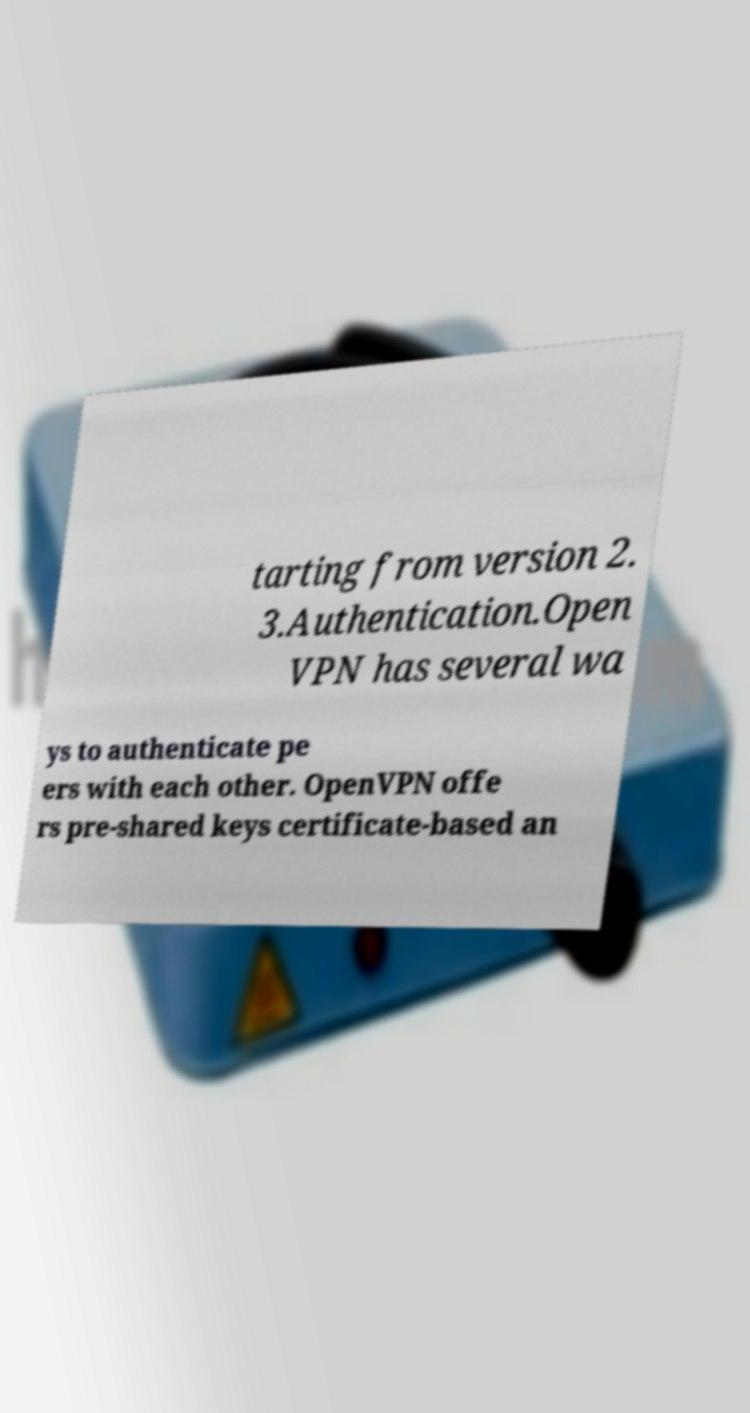There's text embedded in this image that I need extracted. Can you transcribe it verbatim? tarting from version 2. 3.Authentication.Open VPN has several wa ys to authenticate pe ers with each other. OpenVPN offe rs pre-shared keys certificate-based an 